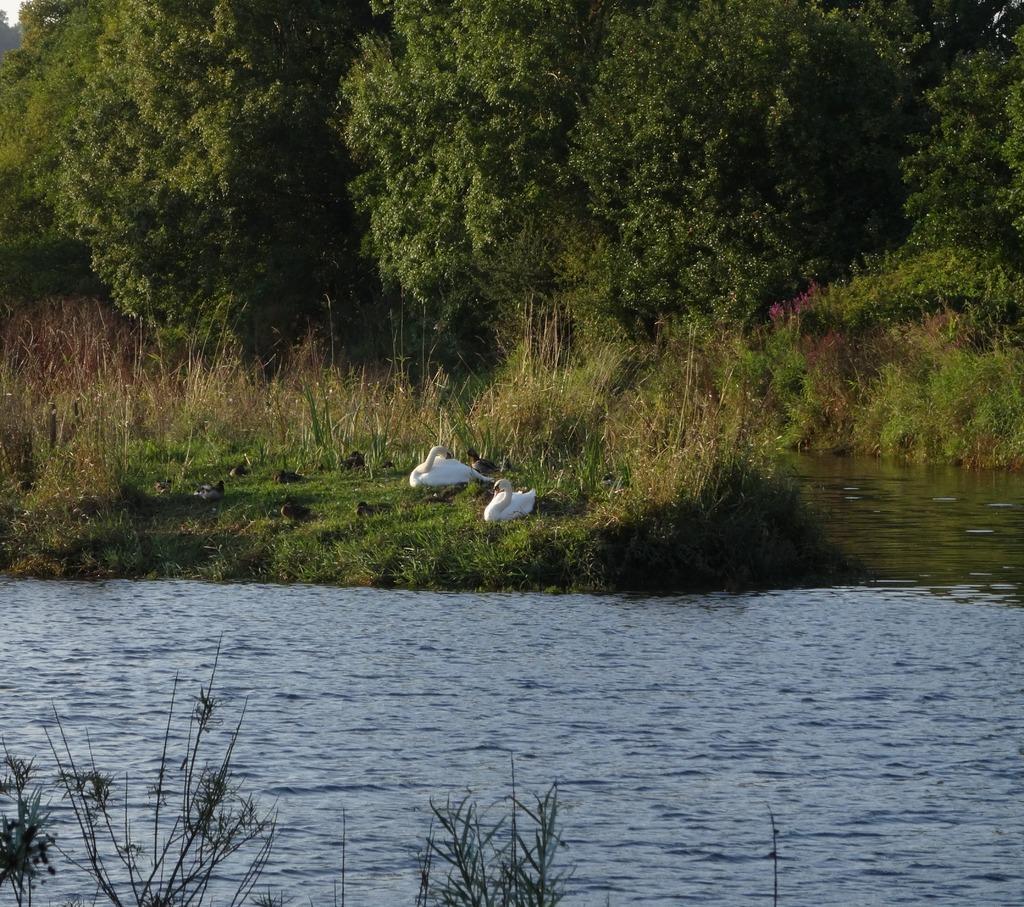Could you give a brief overview of what you see in this image? In this picture I can see couple of swans and I can see water, trees and few plants. 